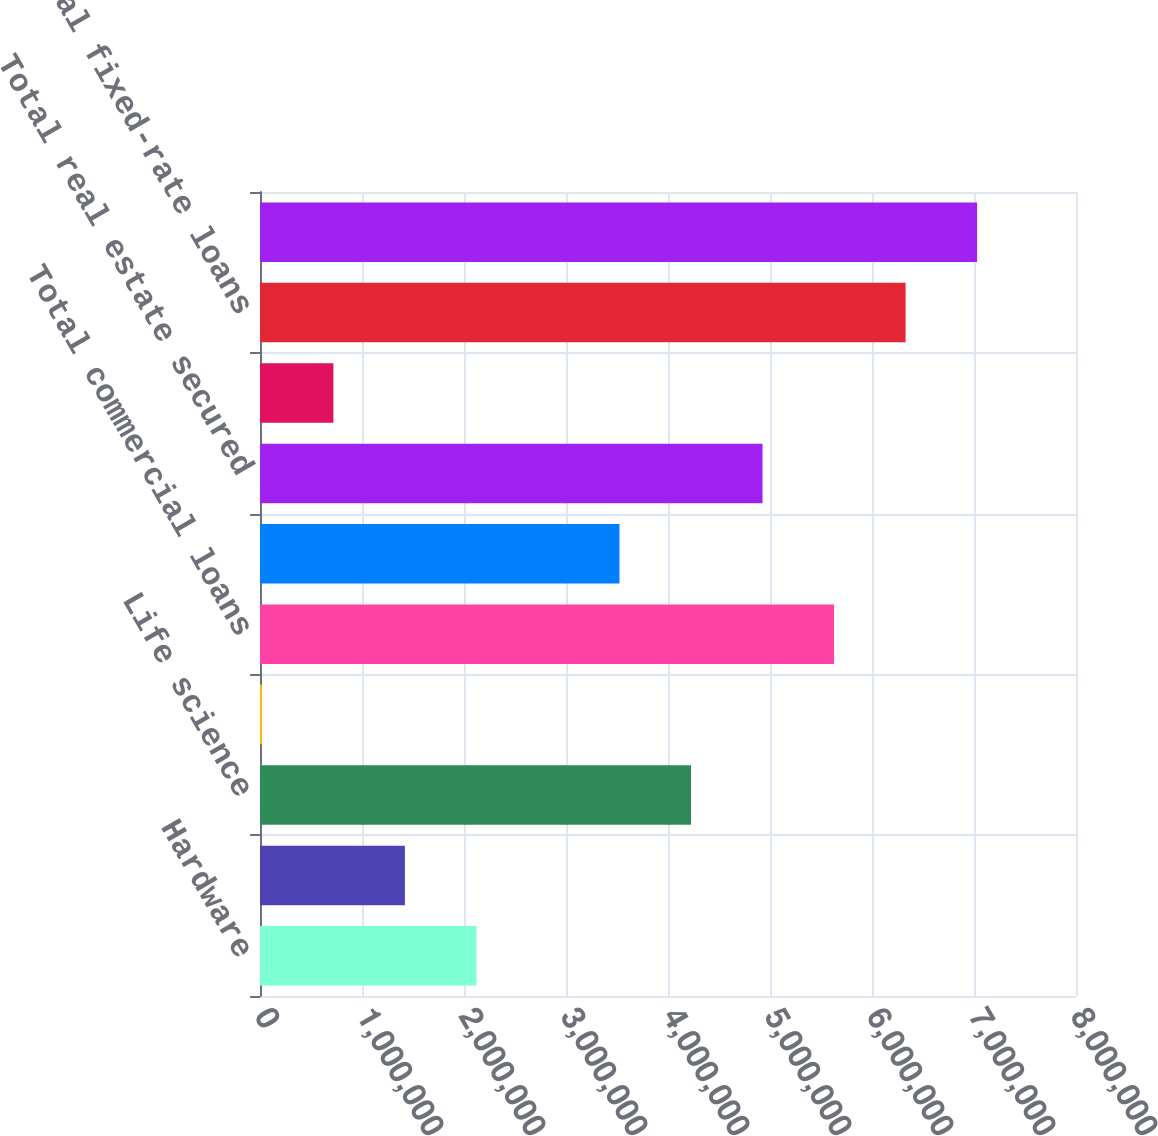Convert chart. <chart><loc_0><loc_0><loc_500><loc_500><bar_chart><fcel>Hardware<fcel>Venture capital/private equity<fcel>Life science<fcel>Premium wine<fcel>Total commercial loans<fcel>Consumer loans<fcel>Total real estate secured<fcel>Construction loans<fcel>Total fixed-rate loans<fcel>Software<nl><fcel>2.12195e+06<fcel>1.42076e+06<fcel>4.22554e+06<fcel>18364<fcel>5.62793e+06<fcel>3.52434e+06<fcel>4.92673e+06<fcel>719560<fcel>6.32913e+06<fcel>7.03032e+06<nl></chart> 